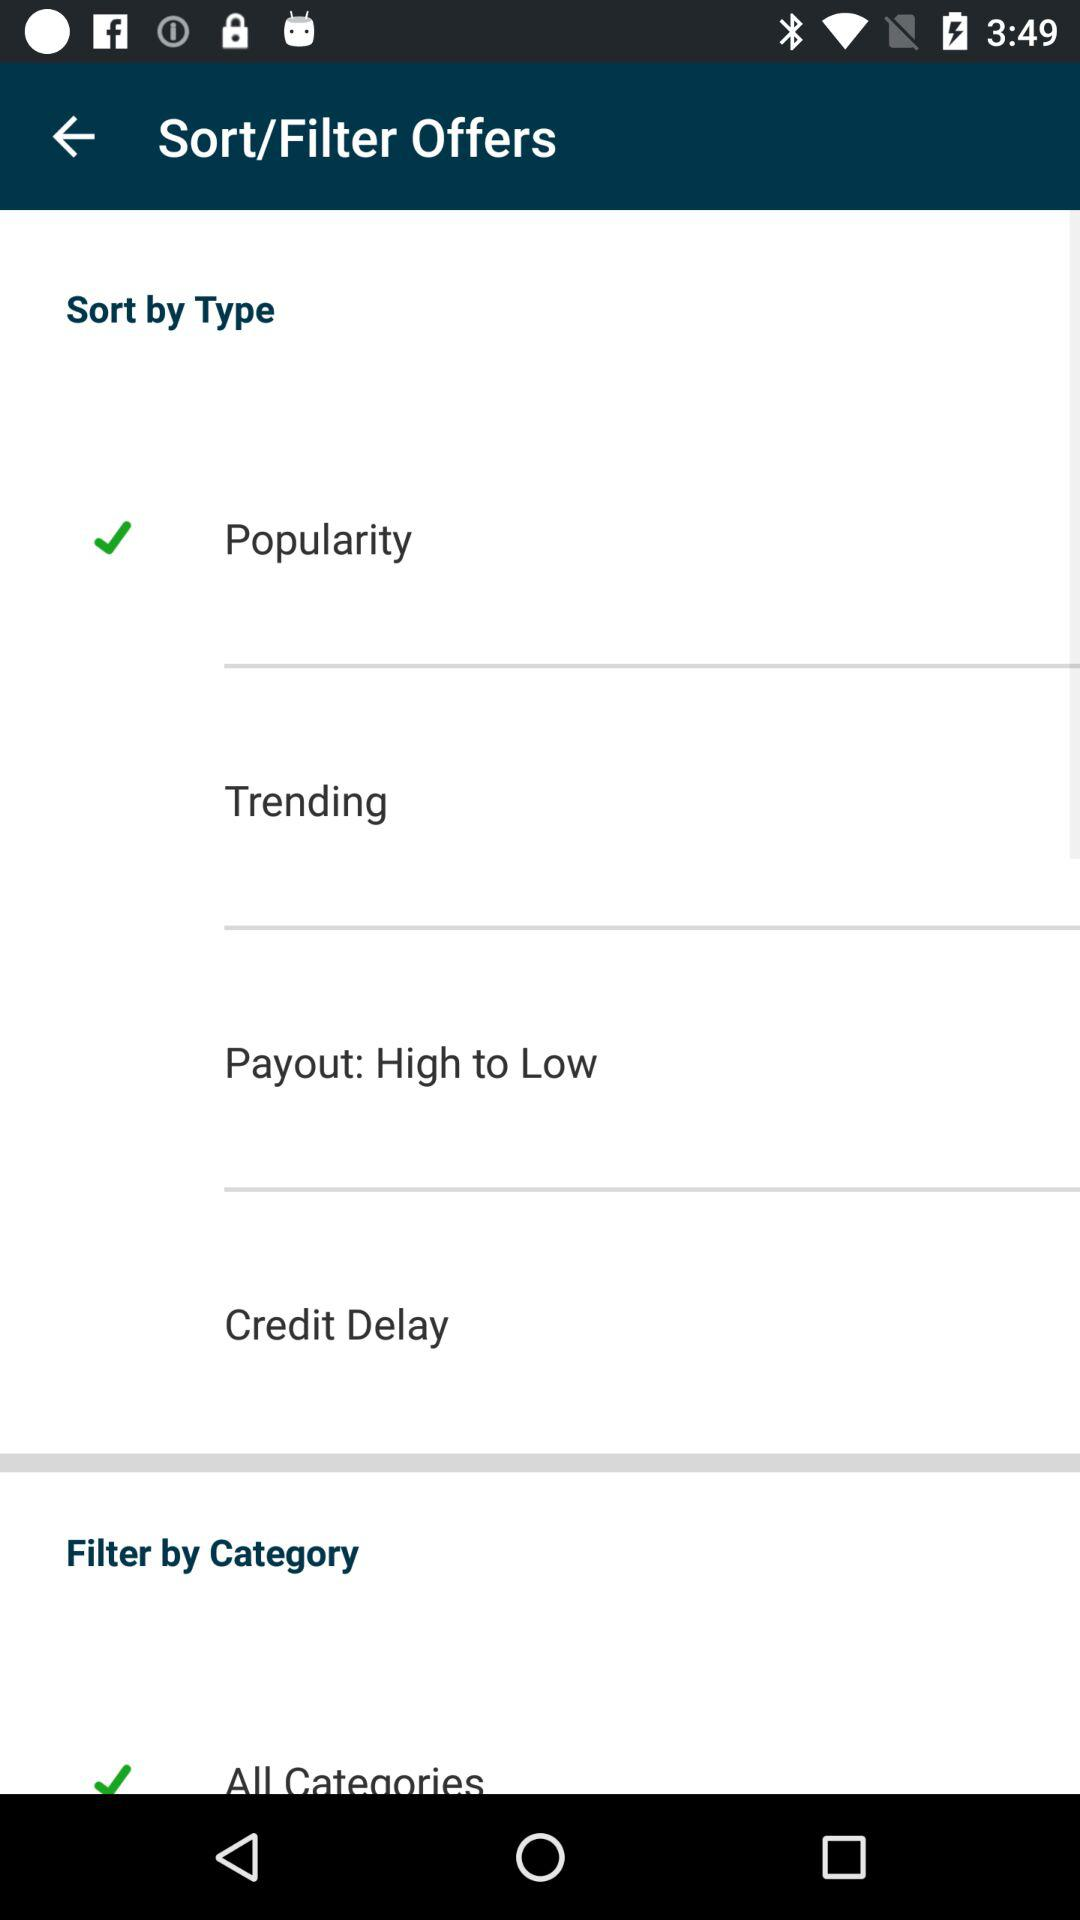Which option is selected in the "Sort by Type"? The selected option is "Popularity". 